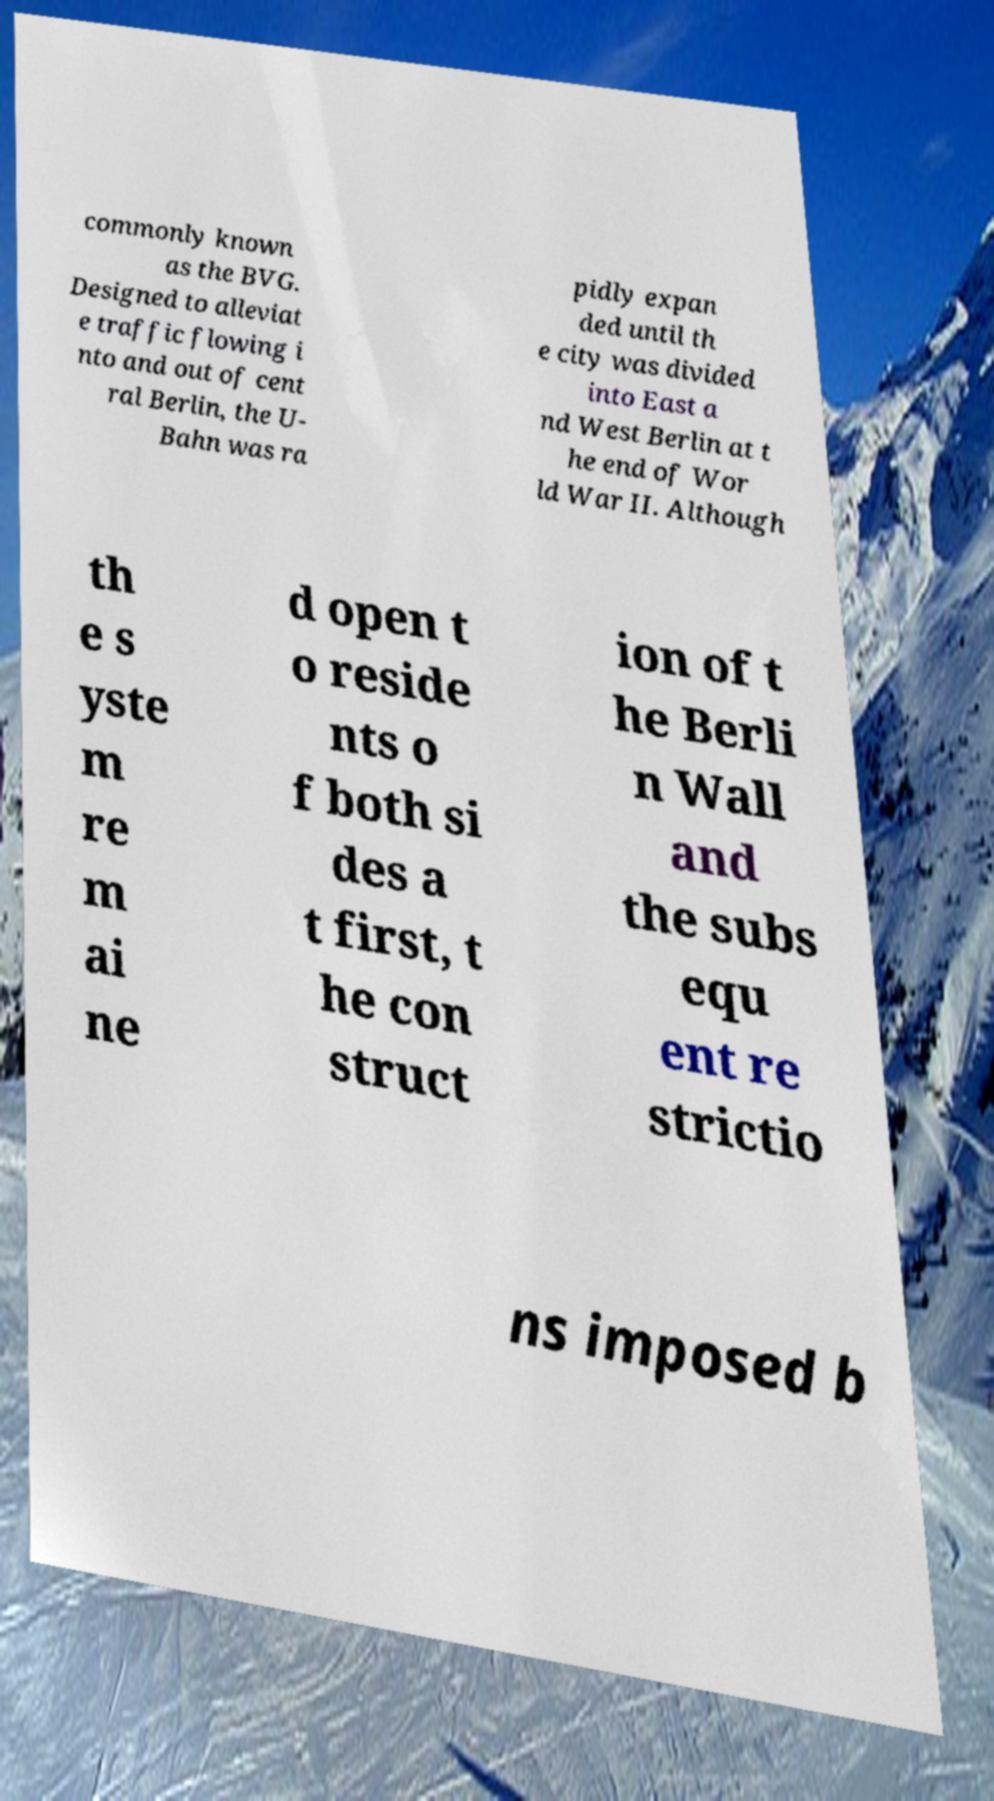Can you read and provide the text displayed in the image?This photo seems to have some interesting text. Can you extract and type it out for me? commonly known as the BVG. Designed to alleviat e traffic flowing i nto and out of cent ral Berlin, the U- Bahn was ra pidly expan ded until th e city was divided into East a nd West Berlin at t he end of Wor ld War II. Although th e s yste m re m ai ne d open t o reside nts o f both si des a t first, t he con struct ion of t he Berli n Wall and the subs equ ent re strictio ns imposed b 